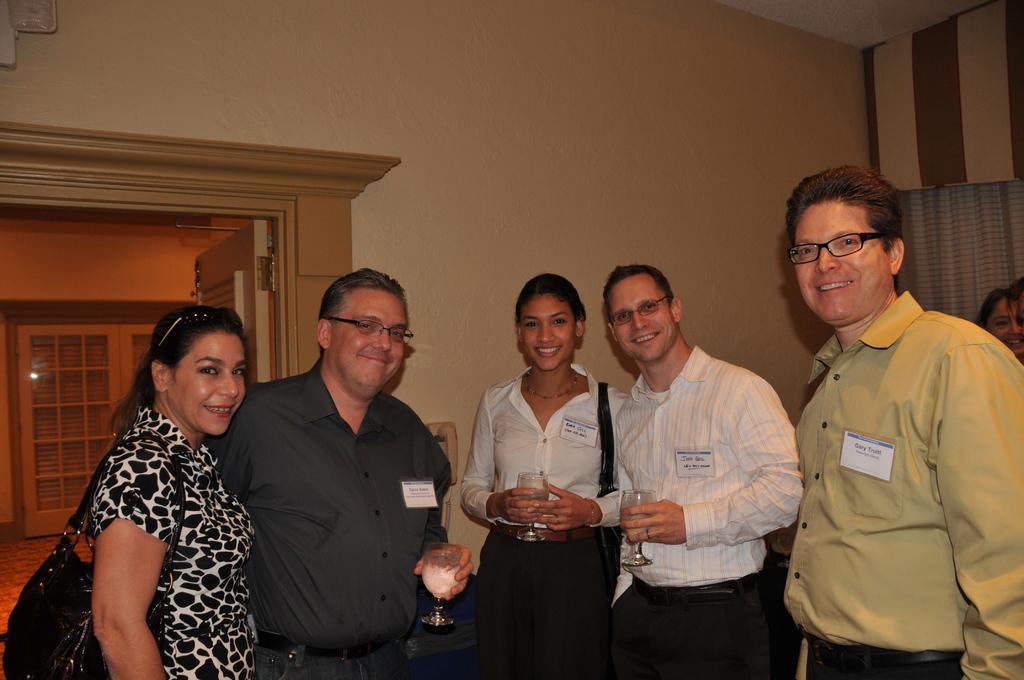Please provide a concise description of this image. In this picture there are people in the center of the image, few of them are holding glasses in their hands and there are other people in the background area of the image, it seems to be there is a lamp in the top left side of the image, it seems to be there is a curtain in the background area of the image and there is a door behind them, it seems to be there is a window in the image. 